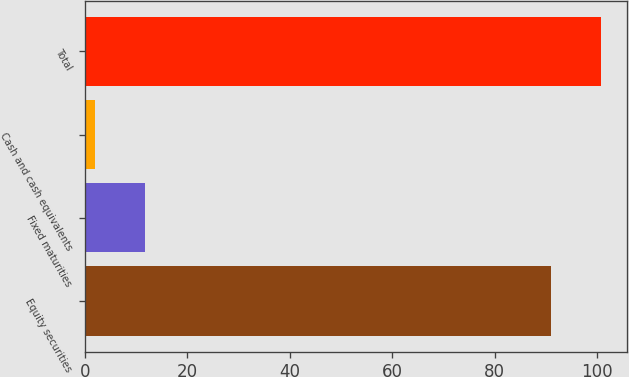<chart> <loc_0><loc_0><loc_500><loc_500><bar_chart><fcel>Equity securities<fcel>Fixed maturities<fcel>Cash and cash equivalents<fcel>Total<nl><fcel>91<fcel>11.8<fcel>2<fcel>100.8<nl></chart> 